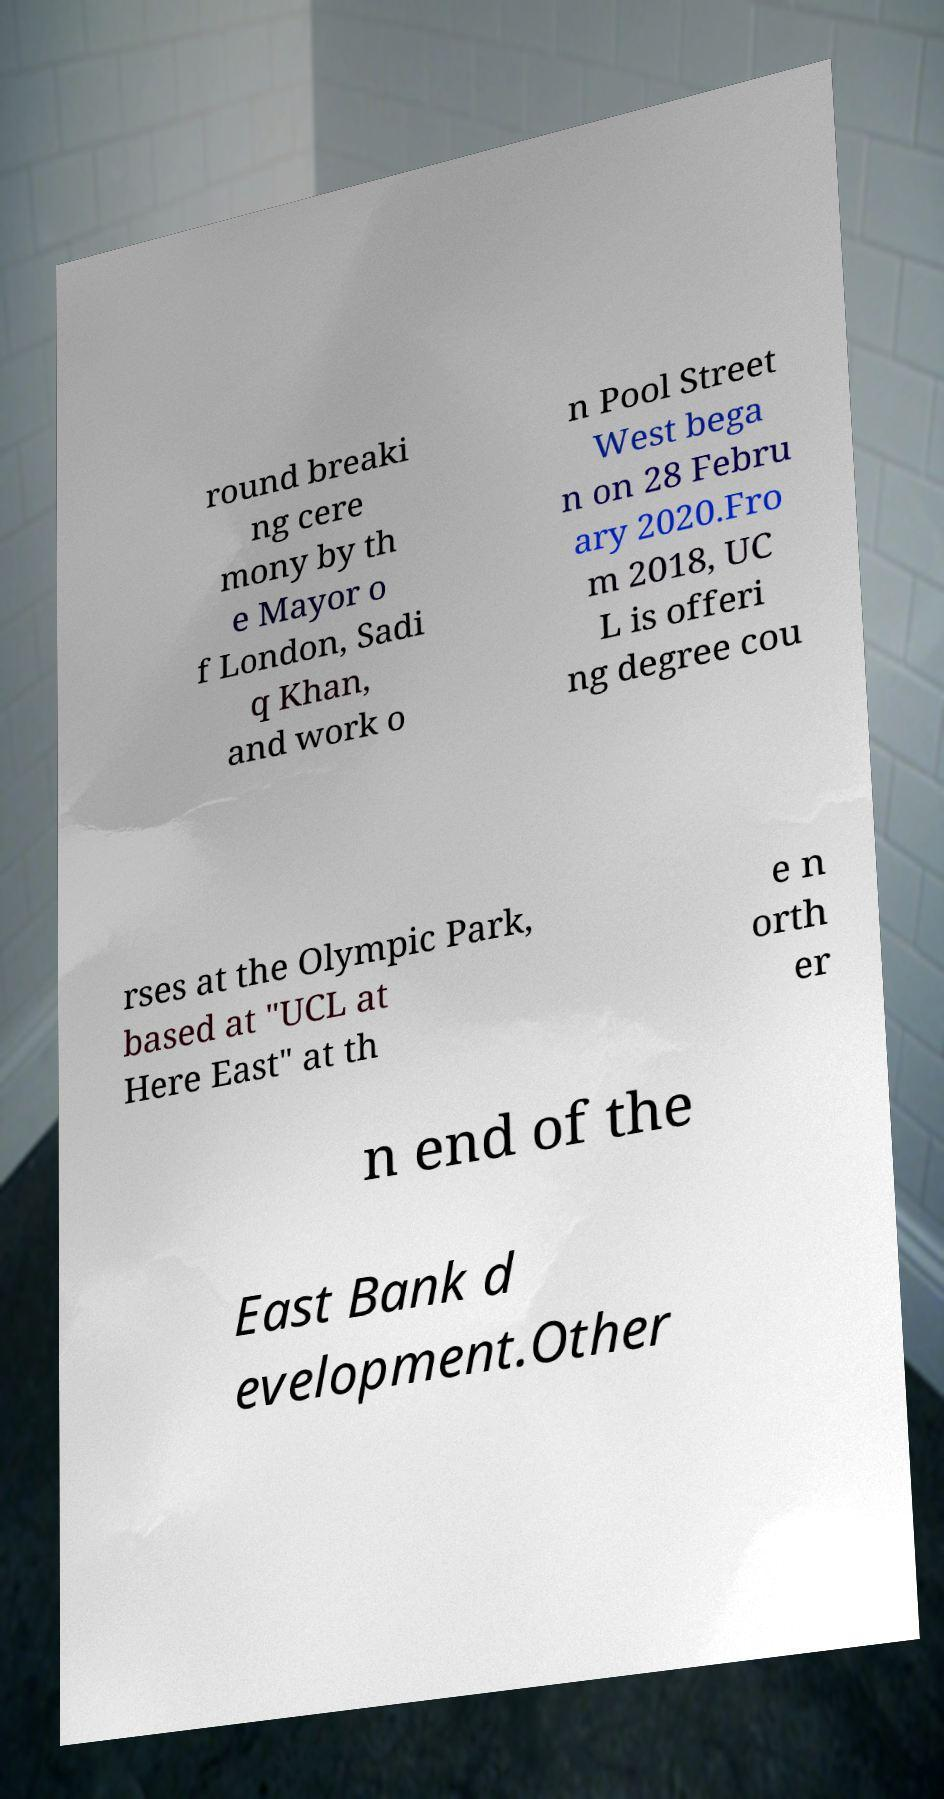Please read and relay the text visible in this image. What does it say? round breaki ng cere mony by th e Mayor o f London, Sadi q Khan, and work o n Pool Street West bega n on 28 Febru ary 2020.Fro m 2018, UC L is offeri ng degree cou rses at the Olympic Park, based at "UCL at Here East" at th e n orth er n end of the East Bank d evelopment.Other 